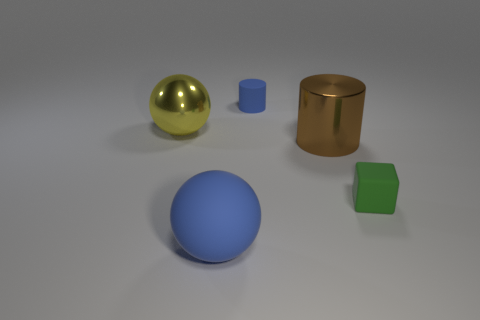What materials do the objects in the image appear to be made of? The objects in the image appear to be rendered with different materials. The sphere in the foreground looks like it could be made of a matte plastic, and the cube is perhaps a metallic or painted wood based on the shine. The larger ball and the cylinder have a shinier, reflective surface suggesting they could be metallic. Lastly, the small blue object looks like it might be made of a similar material as the large sphere.  Can you infer anything about the light source in the scene? The light source in the scene appears to be coming from above based on the shadows cast by the objects. The objects have a soft shadow that indicates the light source might be diffuse or there could be some ambient lighting involved as well. 